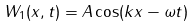Convert formula to latex. <formula><loc_0><loc_0><loc_500><loc_500>W _ { 1 } ( x , t ) = A \cos ( k x - \omega t )</formula> 